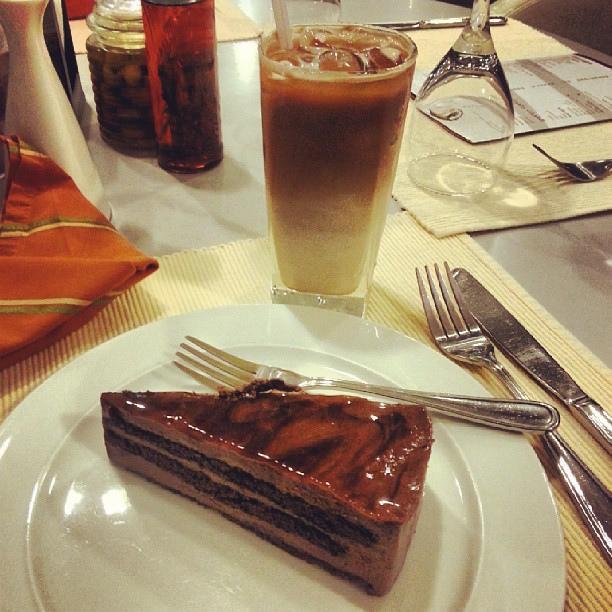How many dining tables are in the photo?
Give a very brief answer. 1. How many cups can be seen?
Give a very brief answer. 2. How many forks are in the photo?
Give a very brief answer. 2. How many sinks are there?
Give a very brief answer. 0. 